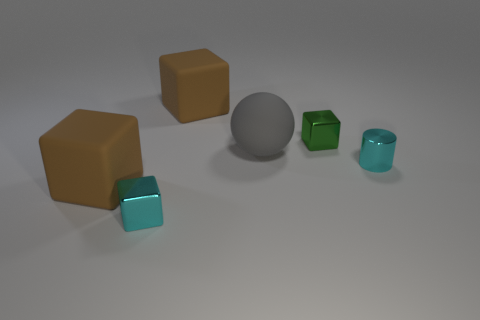What number of objects are shiny cylinders or objects that are behind the rubber sphere?
Keep it short and to the point. 3. What is the color of the matte thing on the left side of the small cube that is in front of the small green shiny cube?
Provide a succinct answer. Brown. What number of other objects are the same material as the tiny cyan block?
Your response must be concise. 2. How many metallic objects are either big gray balls or cyan objects?
Provide a short and direct response. 2. There is another metal object that is the same shape as the green object; what is its color?
Offer a very short reply. Cyan. How many objects are either green metallic spheres or big rubber balls?
Your response must be concise. 1. The tiny green thing that is the same material as the tiny cyan cylinder is what shape?
Give a very brief answer. Cube. How many big objects are either green shiny cylinders or brown rubber things?
Offer a very short reply. 2. How many other things are the same color as the big ball?
Ensure brevity in your answer.  0. How many large rubber things are to the right of the big rubber block to the left of the large brown matte object behind the small cyan shiny cylinder?
Make the answer very short. 2. 